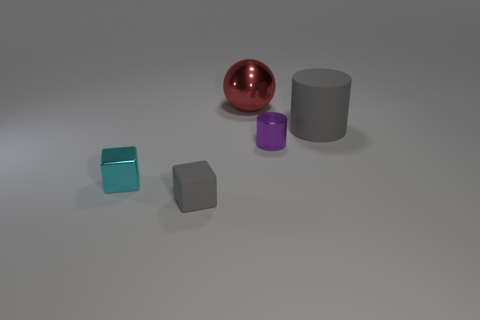What could be the relative sizes of these objects? From the perspective given, the red sphere appears to be the largest in diameter, followed by the gray cylinder. The teal and matte gray cubes look to be of smaller dimension, with the teal cube being slightly larger than the gray cube. The purple cylinder is the smallest object on display. 